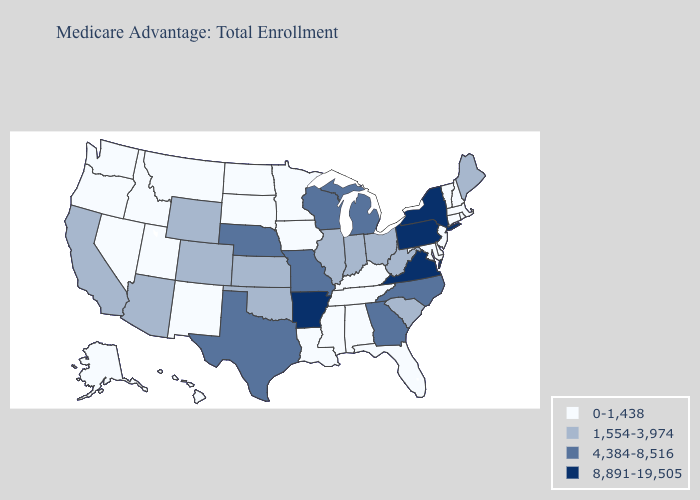Name the states that have a value in the range 4,384-8,516?
Short answer required. Georgia, Michigan, Missouri, Nebraska, North Carolina, Texas, Wisconsin. What is the value of North Dakota?
Short answer required. 0-1,438. Name the states that have a value in the range 4,384-8,516?
Concise answer only. Georgia, Michigan, Missouri, Nebraska, North Carolina, Texas, Wisconsin. Does the map have missing data?
Answer briefly. No. Does Washington have a lower value than Hawaii?
Short answer required. No. What is the lowest value in states that border Kansas?
Give a very brief answer. 1,554-3,974. Name the states that have a value in the range 4,384-8,516?
Keep it brief. Georgia, Michigan, Missouri, Nebraska, North Carolina, Texas, Wisconsin. Which states have the lowest value in the West?
Write a very short answer. Alaska, Hawaii, Idaho, Montana, Nevada, New Mexico, Oregon, Utah, Washington. Among the states that border Michigan , which have the lowest value?
Give a very brief answer. Indiana, Ohio. What is the highest value in states that border Florida?
Give a very brief answer. 4,384-8,516. Which states have the lowest value in the MidWest?
Write a very short answer. Iowa, Minnesota, North Dakota, South Dakota. Which states hav the highest value in the MidWest?
Write a very short answer. Michigan, Missouri, Nebraska, Wisconsin. Does the first symbol in the legend represent the smallest category?
Concise answer only. Yes. Does the first symbol in the legend represent the smallest category?
Quick response, please. Yes. Which states have the lowest value in the USA?
Give a very brief answer. Alabama, Alaska, Connecticut, Delaware, Florida, Hawaii, Idaho, Iowa, Kentucky, Louisiana, Maryland, Massachusetts, Minnesota, Mississippi, Montana, Nevada, New Hampshire, New Jersey, New Mexico, North Dakota, Oregon, Rhode Island, South Dakota, Tennessee, Utah, Vermont, Washington. 